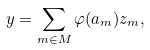Convert formula to latex. <formula><loc_0><loc_0><loc_500><loc_500>y = \sum _ { m \in M } \varphi ( a _ { m } ) z _ { m } ,</formula> 